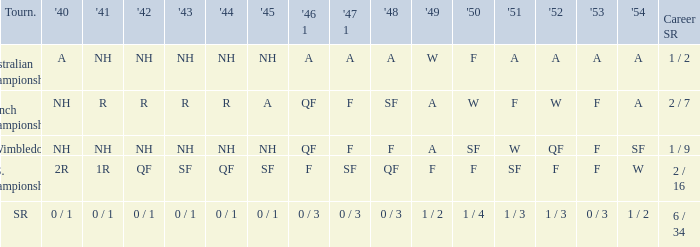What is the tournament that had a result of A in 1954 and NH in 1942? Australian Championships. 